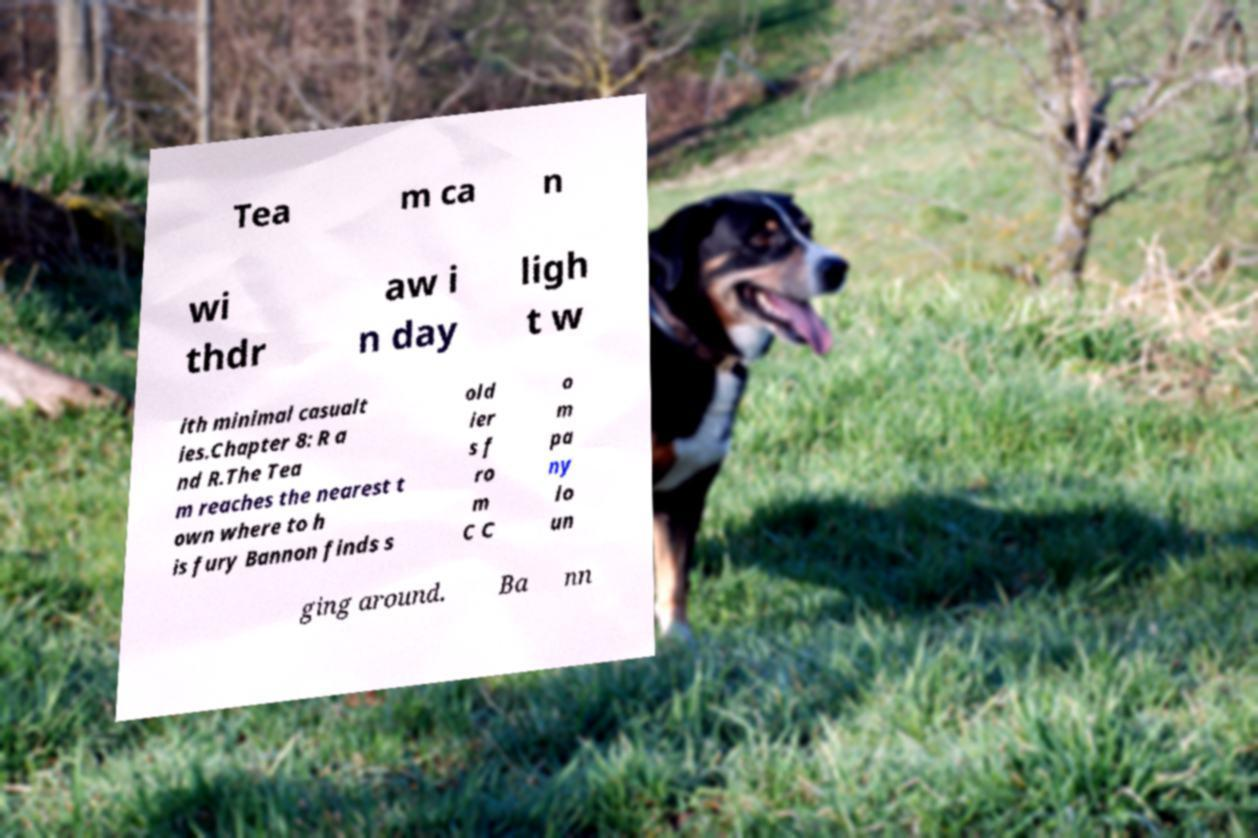Can you read and provide the text displayed in the image?This photo seems to have some interesting text. Can you extract and type it out for me? Tea m ca n wi thdr aw i n day ligh t w ith minimal casualt ies.Chapter 8: R a nd R.The Tea m reaches the nearest t own where to h is fury Bannon finds s old ier s f ro m C C o m pa ny lo un ging around. Ba nn 